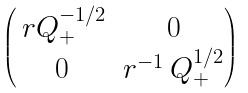<formula> <loc_0><loc_0><loc_500><loc_500>\begin{pmatrix} \, r Q _ { + } ^ { - 1 / 2 } & 0 \\ 0 & r ^ { - 1 } \, Q _ { + } ^ { 1 / 2 } \end{pmatrix}</formula> 